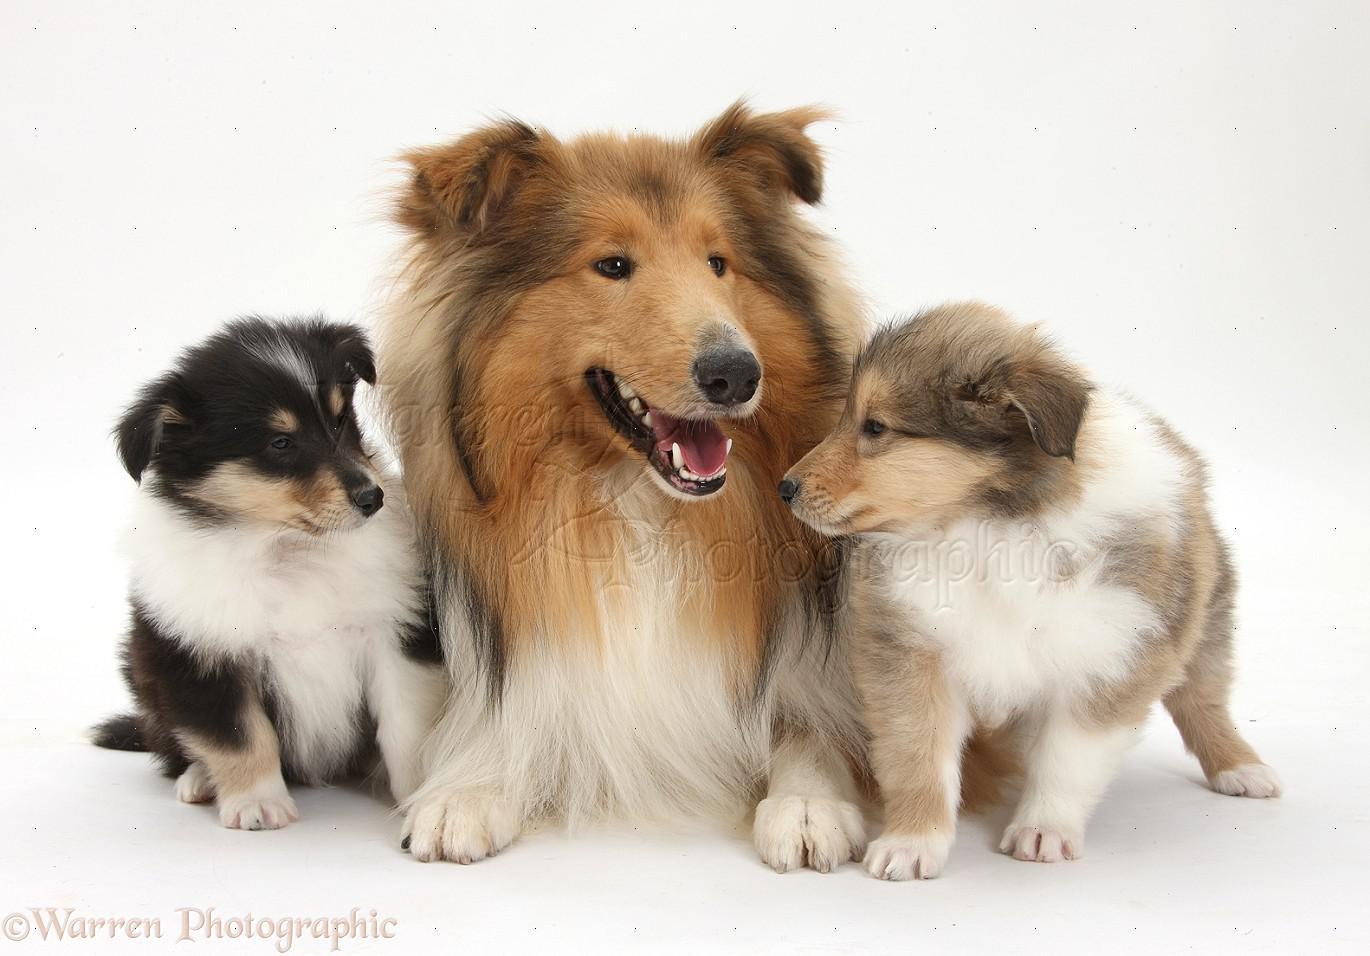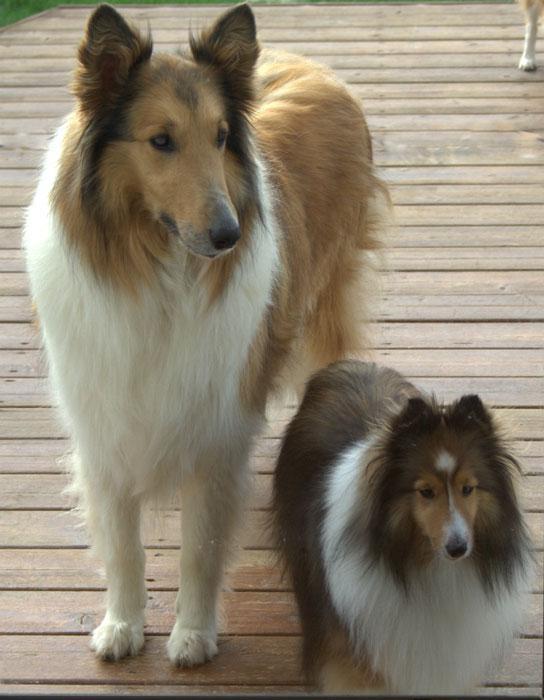The first image is the image on the left, the second image is the image on the right. Examine the images to the left and right. Is the description "There are five collies in total." accurate? Answer yes or no. Yes. The first image is the image on the left, the second image is the image on the right. For the images shown, is this caption "One image contains three collie dogs, and the other contains two." true? Answer yes or no. Yes. 